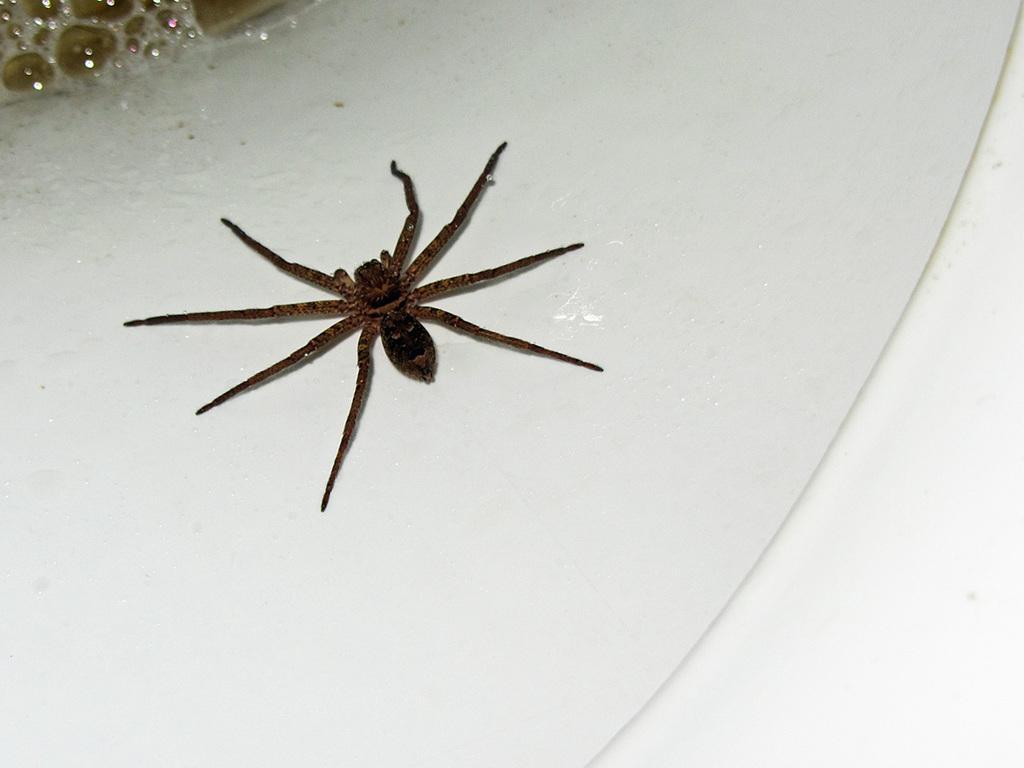Could you give a brief overview of what you see in this image? In the image we can see a sink, on the sink there is a spider. 